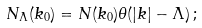Convert formula to latex. <formula><loc_0><loc_0><loc_500><loc_500>N _ { \Lambda } ( k _ { 0 } ) = N ( k _ { 0 } ) \theta ( | { k } | - \Lambda ) \, ;</formula> 